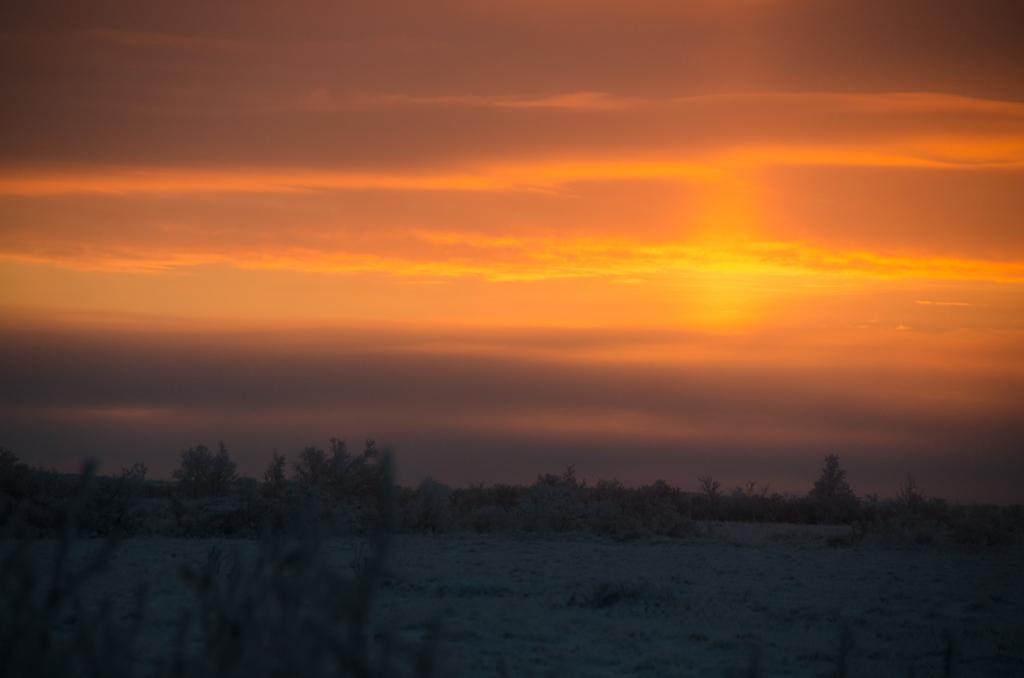How would you summarize this image in a sentence or two? In this image there are plants, in the background there is red sky. 